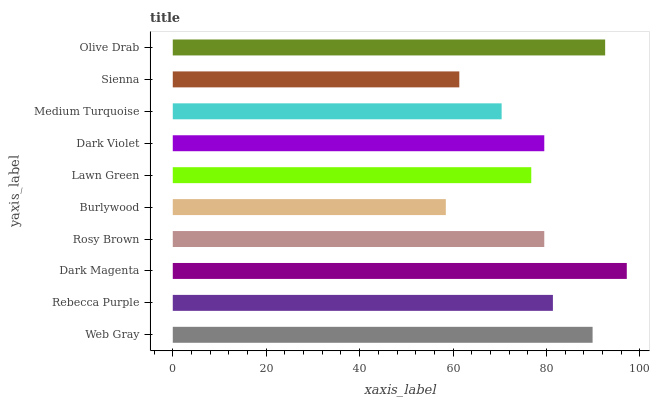Is Burlywood the minimum?
Answer yes or no. Yes. Is Dark Magenta the maximum?
Answer yes or no. Yes. Is Rebecca Purple the minimum?
Answer yes or no. No. Is Rebecca Purple the maximum?
Answer yes or no. No. Is Web Gray greater than Rebecca Purple?
Answer yes or no. Yes. Is Rebecca Purple less than Web Gray?
Answer yes or no. Yes. Is Rebecca Purple greater than Web Gray?
Answer yes or no. No. Is Web Gray less than Rebecca Purple?
Answer yes or no. No. Is Dark Violet the high median?
Answer yes or no. Yes. Is Rosy Brown the low median?
Answer yes or no. Yes. Is Olive Drab the high median?
Answer yes or no. No. Is Rebecca Purple the low median?
Answer yes or no. No. 